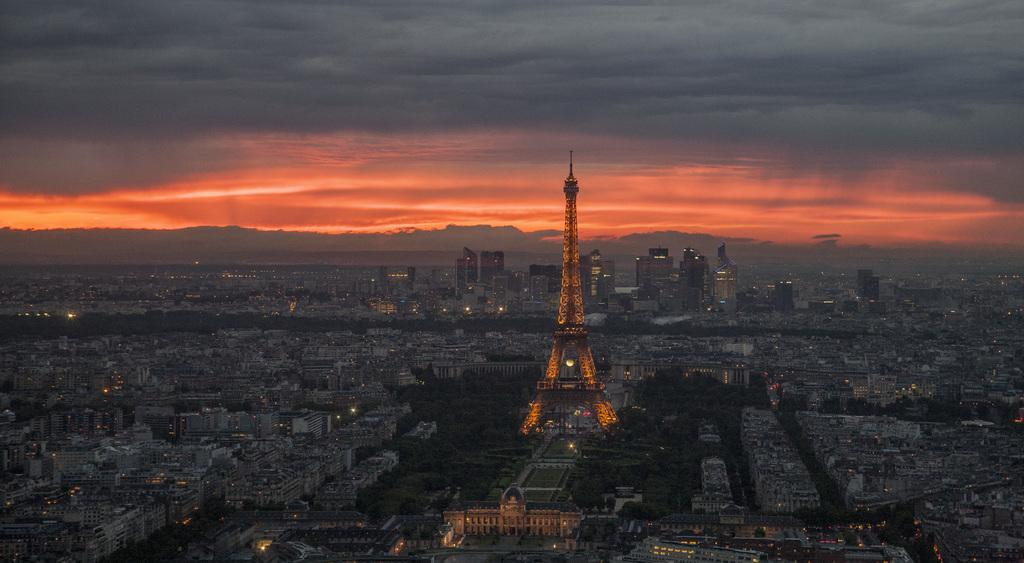What is the main subject of the picture? The main subject of the picture is the Eiffel tower. What can be seen in the background of the picture? There are many buildings and a few lights in the background of the picture. Can you see a cat climbing the Eiffel tower in the picture? No, there is no cat present in the image. 